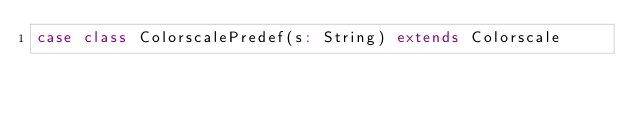<code> <loc_0><loc_0><loc_500><loc_500><_Scala_>case class ColorscalePredef(s: String) extends Colorscale
</code> 